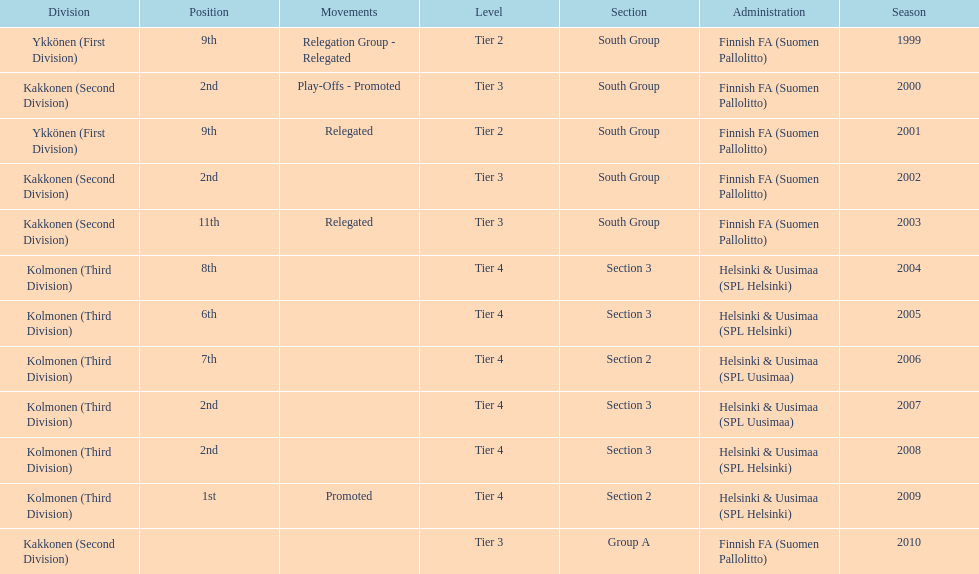Which was the only kolmonen whose movements were promoted? 2009. 